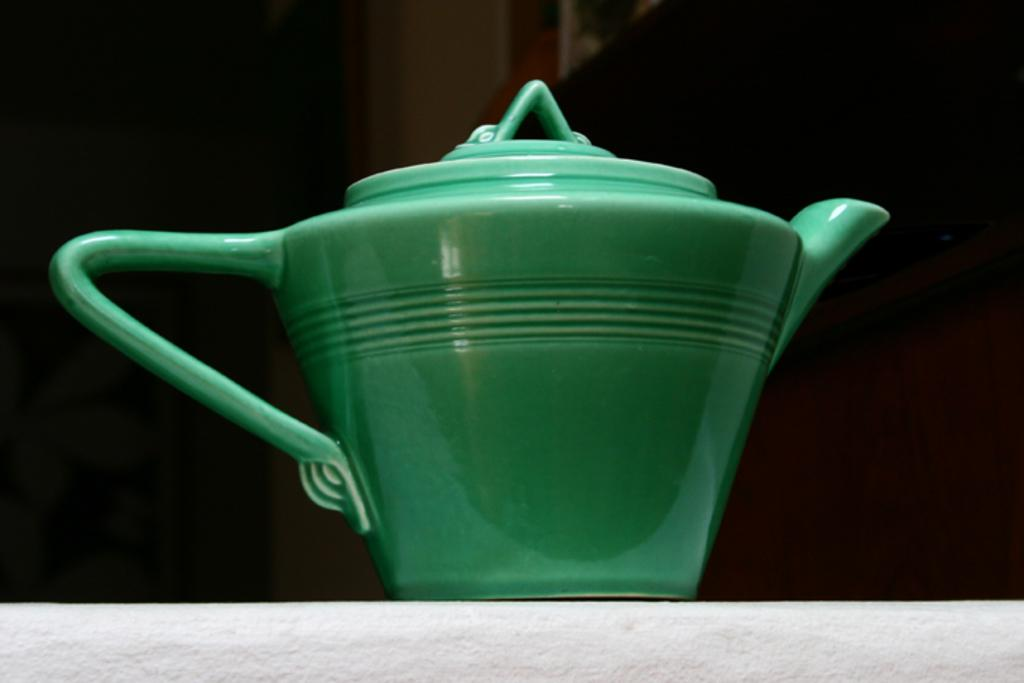What color is the kettle in the image? The kettle in the image is green. Can you describe the background behind the kettle? There is a wall visible behind the kettle in the image. How many sacks can be seen hanging from the wall behind the kettle? There are no sacks visible hanging from the wall behind the kettle in the image. What type of flower is growing on the wall behind the kettle? There are no flowers visible on the wall behind the kettle in the image. 